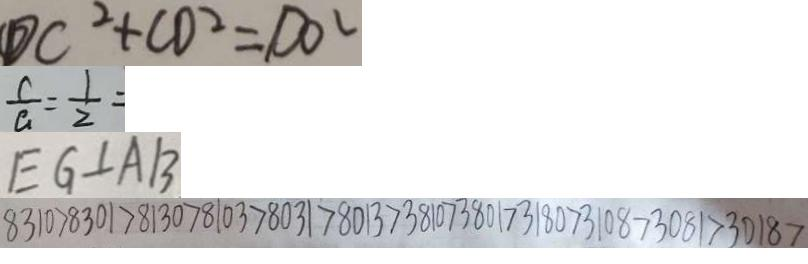<formula> <loc_0><loc_0><loc_500><loc_500>D C ^ { 2 } + C D ^ { 2 } = D O ^ { 2 } 
 \frac { c } { a } = \frac { 1 } { 2 } = 
 E G \bot A B 
 8 3 1 0 > 8 3 0 1 > 8 1 3 0 > 8 1 0 3 > 8 0 3 1 > 8 0 1 3 > 3 8 1 0 > 3 8 0 1 > 3 1 8 0 > 3 0 8 1 > 3 0 8 1 > 3 0 1 8 ></formula> 